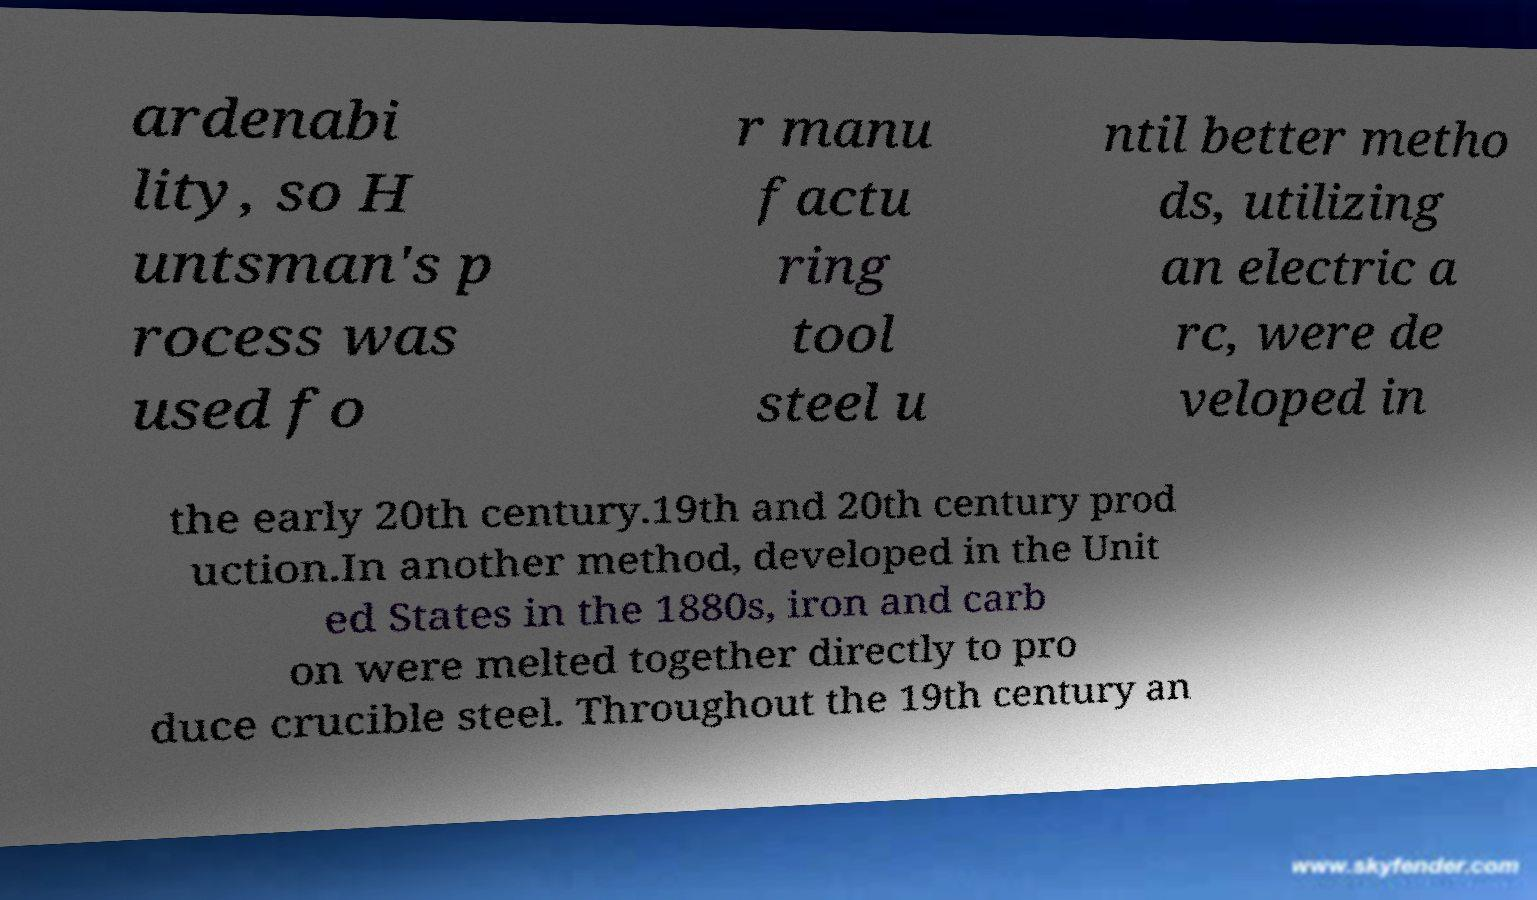For documentation purposes, I need the text within this image transcribed. Could you provide that? ardenabi lity, so H untsman's p rocess was used fo r manu factu ring tool steel u ntil better metho ds, utilizing an electric a rc, were de veloped in the early 20th century.19th and 20th century prod uction.In another method, developed in the Unit ed States in the 1880s, iron and carb on were melted together directly to pro duce crucible steel. Throughout the 19th century an 